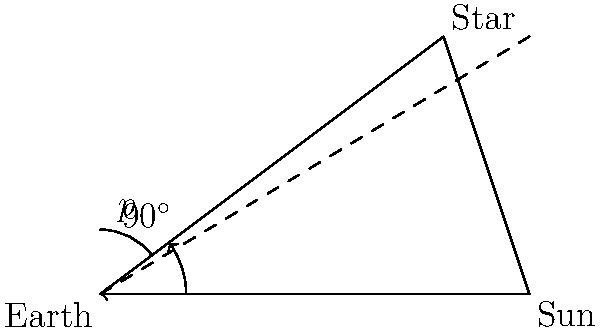As a construction worker familiar with using drones for 3D mapping, you understand the importance of precise measurements. In astronomy, parallax is used to measure distances to stars. If the parallax angle ($p$) of a star is 0.5 arcseconds when Earth is at opposite points in its orbit around the Sun, what is the distance to the star in parsecs? To solve this problem, let's break it down into steps:

1) First, recall the definition of a parsec: it's the distance at which an object has a parallax of 1 arcsecond.

2) The formula relating distance (d) in parsecs to parallax (p) in arcseconds is:

   $$d = \frac{1}{p}$$

3) In this case, we're given that $p = 0.5$ arcseconds.

4) Plugging this into our formula:

   $$d = \frac{1}{0.5}$$

5) Simplify:

   $$d = 2$$

6) Therefore, the star is 2 parsecs away.

This method is similar to how drones use triangulation for 3D mapping in construction, but on a much larger scale!
Answer: 2 parsecs 